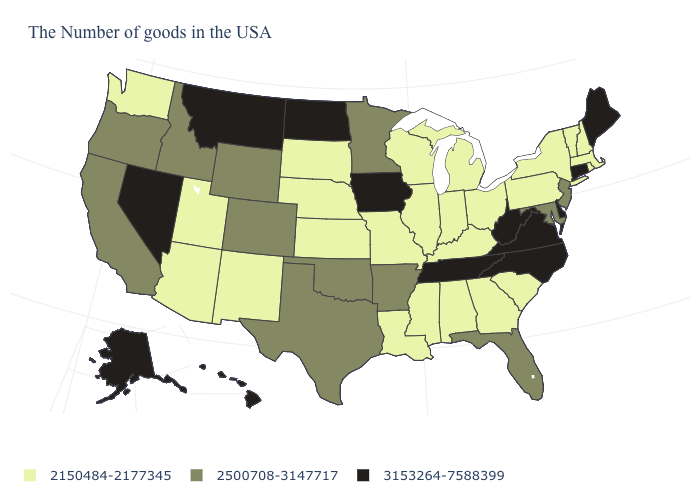What is the lowest value in states that border Massachusetts?
Keep it brief. 2150484-2177345. What is the value of Minnesota?
Be succinct. 2500708-3147717. What is the value of Minnesota?
Short answer required. 2500708-3147717. What is the value of Kentucky?
Answer briefly. 2150484-2177345. Name the states that have a value in the range 3153264-7588399?
Answer briefly. Maine, Connecticut, Delaware, Virginia, North Carolina, West Virginia, Tennessee, Iowa, North Dakota, Montana, Nevada, Alaska, Hawaii. What is the highest value in states that border Pennsylvania?
Give a very brief answer. 3153264-7588399. Among the states that border Washington , which have the lowest value?
Keep it brief. Idaho, Oregon. What is the lowest value in the MidWest?
Quick response, please. 2150484-2177345. Name the states that have a value in the range 2500708-3147717?
Answer briefly. New Jersey, Maryland, Florida, Arkansas, Minnesota, Oklahoma, Texas, Wyoming, Colorado, Idaho, California, Oregon. Which states hav the highest value in the West?
Answer briefly. Montana, Nevada, Alaska, Hawaii. What is the lowest value in the West?
Quick response, please. 2150484-2177345. Does Oklahoma have the highest value in the USA?
Be succinct. No. Does Idaho have the same value as Connecticut?
Give a very brief answer. No. Which states have the lowest value in the Northeast?
Concise answer only. Massachusetts, Rhode Island, New Hampshire, Vermont, New York, Pennsylvania. Does the first symbol in the legend represent the smallest category?
Short answer required. Yes. 